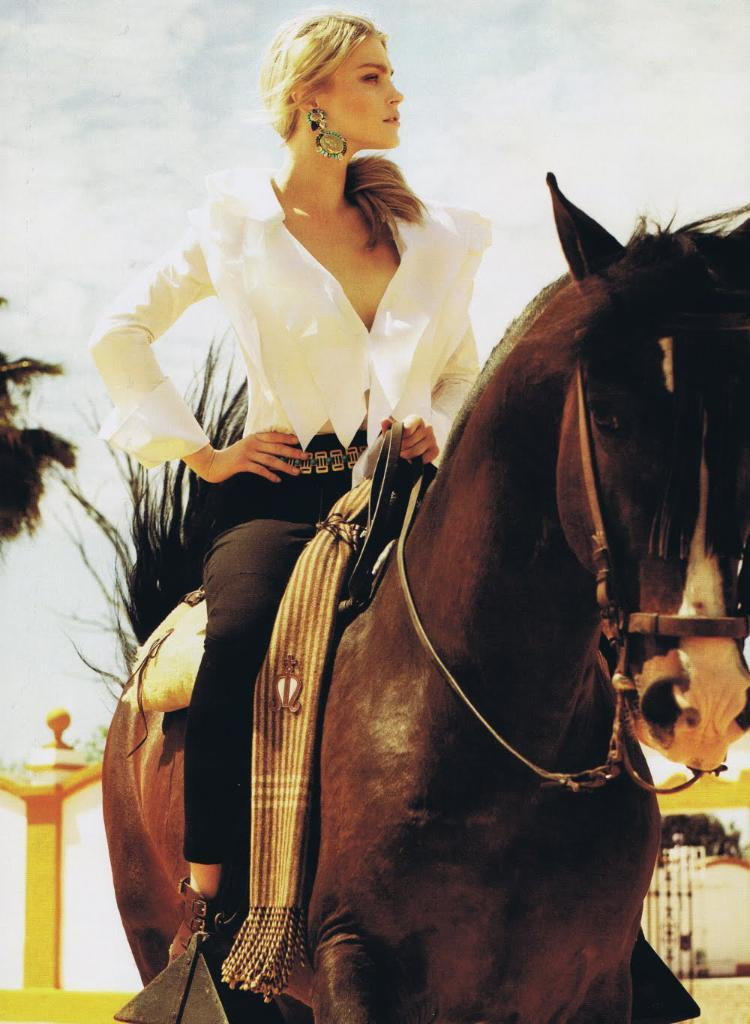Who is the main subject in the image? There is a woman in the image. What is the woman doing in the image? The woman is sitting on a horse. What can be seen in the sky in the image? The sky is visible in the image, and there are clouds in the sky. What type of vegetation is present in the image? There are trees in the image. Can you describe any other objects in the image? There are other unspecified objects in the image. What type of parcel is the woman holding while riding the horse in the image? There is no parcel visible in the image; the woman is simply sitting on the horse. What type of education is the woman pursuing while riding the horse in the image? There is no indication of the woman pursuing any education in the image; she is simply sitting on the horse. 